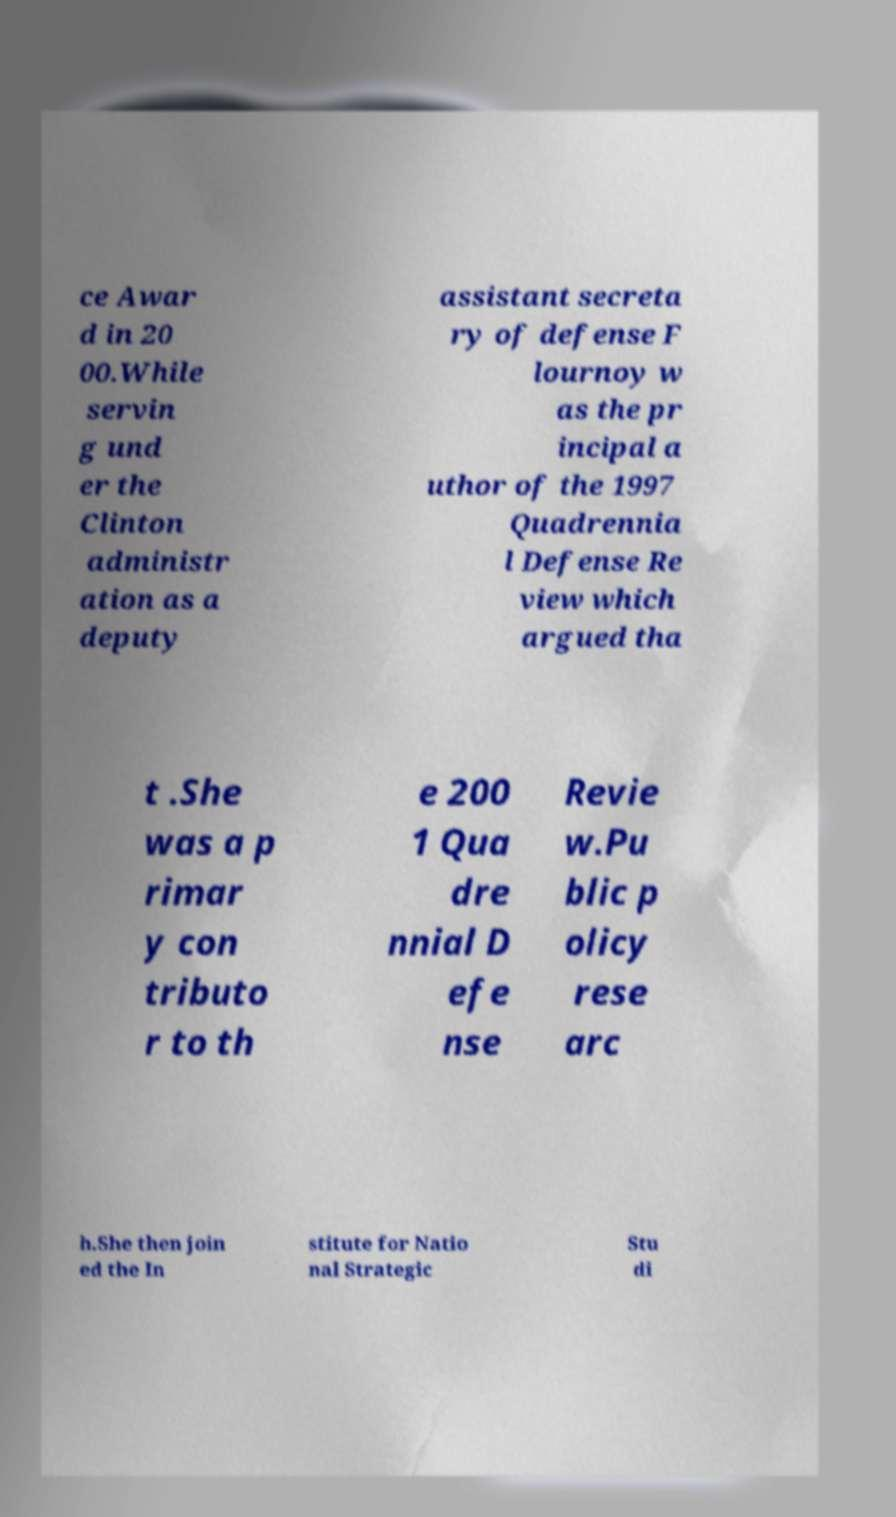Can you accurately transcribe the text from the provided image for me? ce Awar d in 20 00.While servin g und er the Clinton administr ation as a deputy assistant secreta ry of defense F lournoy w as the pr incipal a uthor of the 1997 Quadrennia l Defense Re view which argued tha t .She was a p rimar y con tributo r to th e 200 1 Qua dre nnial D efe nse Revie w.Pu blic p olicy rese arc h.She then join ed the In stitute for Natio nal Strategic Stu di 